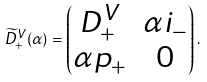<formula> <loc_0><loc_0><loc_500><loc_500>\widetilde { D } ^ { V } _ { + } ( \alpha ) = \begin{pmatrix} D ^ { V } _ { + } & \alpha i _ { - } \\ \alpha p _ { + } & 0 \end{pmatrix} .</formula> 